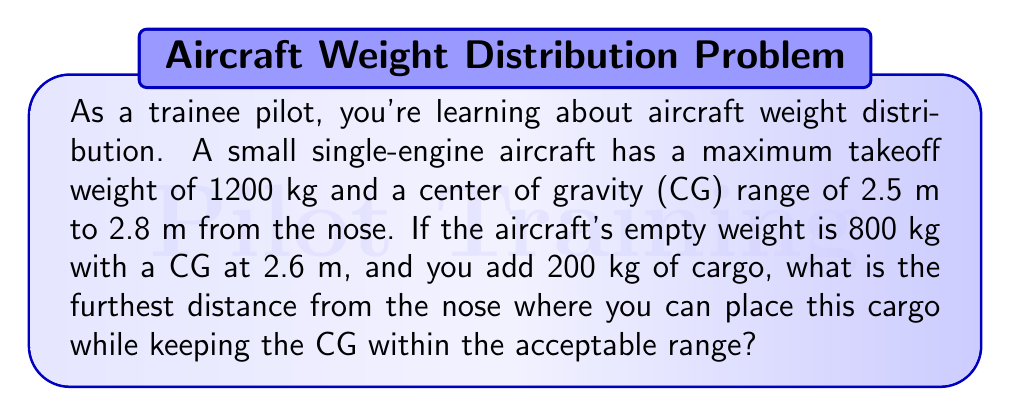Could you help me with this problem? Let's approach this step-by-step:

1) First, we need to calculate the total moment of the empty aircraft:
   $M_{empty} = 800 \text{ kg} \times 2.6 \text{ m} = 2080 \text{ kg}\cdot\text{m}$

2) The total weight after adding cargo is:
   $W_{total} = 800 \text{ kg} + 200 \text{ kg} = 1000 \text{ kg}$

3) To stay within the CG range, the furthest we can place the cargo is when the new CG is at 2.8 m. Let's call the distance of the cargo from the nose $x$. We can set up a moment equation:

   $$\frac{2080 \text{ kg}\cdot\text{m} + 200 \text{ kg} \times x}{1000 \text{ kg}} = 2.8 \text{ m}$$

4) Multiply both sides by 1000 kg:
   $2080 \text{ kg}\cdot\text{m} + 200 \text{ kg} \times x = 2800 \text{ kg}\cdot\text{m}$

5) Subtract 2080 kg⋅m from both sides:
   $200 \text{ kg} \times x = 720 \text{ kg}\cdot\text{m}$

6) Divide both sides by 200 kg:
   $x = 3.6 \text{ m}$

Therefore, the furthest distance from the nose where you can place the 200 kg cargo is 3.6 m.
Answer: 3.6 m 